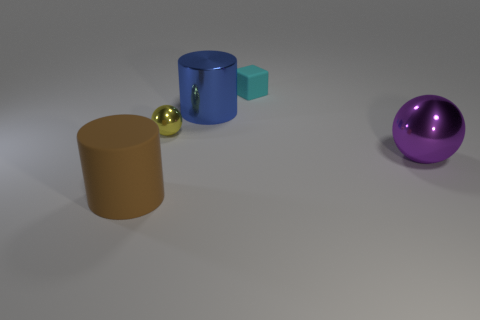Is the purple object made of the same material as the cyan block?
Your answer should be very brief. No. What number of cylinders are either tiny cyan rubber objects or purple shiny things?
Ensure brevity in your answer.  0. What color is the tiny thing to the right of the blue cylinder?
Provide a short and direct response. Cyan. What number of metallic things are tiny brown things or cyan things?
Offer a very short reply. 0. There is a ball to the right of the big cylinder behind the brown matte cylinder; what is it made of?
Your response must be concise. Metal. The large rubber thing has what color?
Your response must be concise. Brown. Is there a small metal object that is on the right side of the rubber thing in front of the tiny cyan object?
Make the answer very short. Yes. What is the material of the blue object?
Your answer should be very brief. Metal. Is the material of the big cylinder to the left of the blue object the same as the ball to the left of the blue metal cylinder?
Ensure brevity in your answer.  No. Are there any other things that have the same color as the tiny matte thing?
Offer a very short reply. No. 